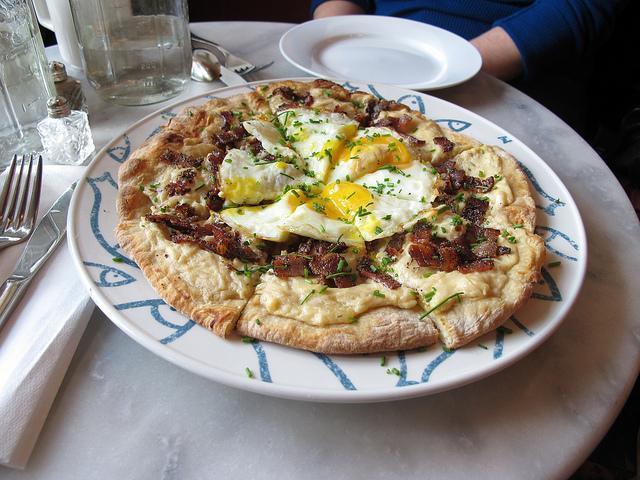How many pizzas are there?
Give a very brief answer. 1. How many cups are in the photo?
Give a very brief answer. 2. 